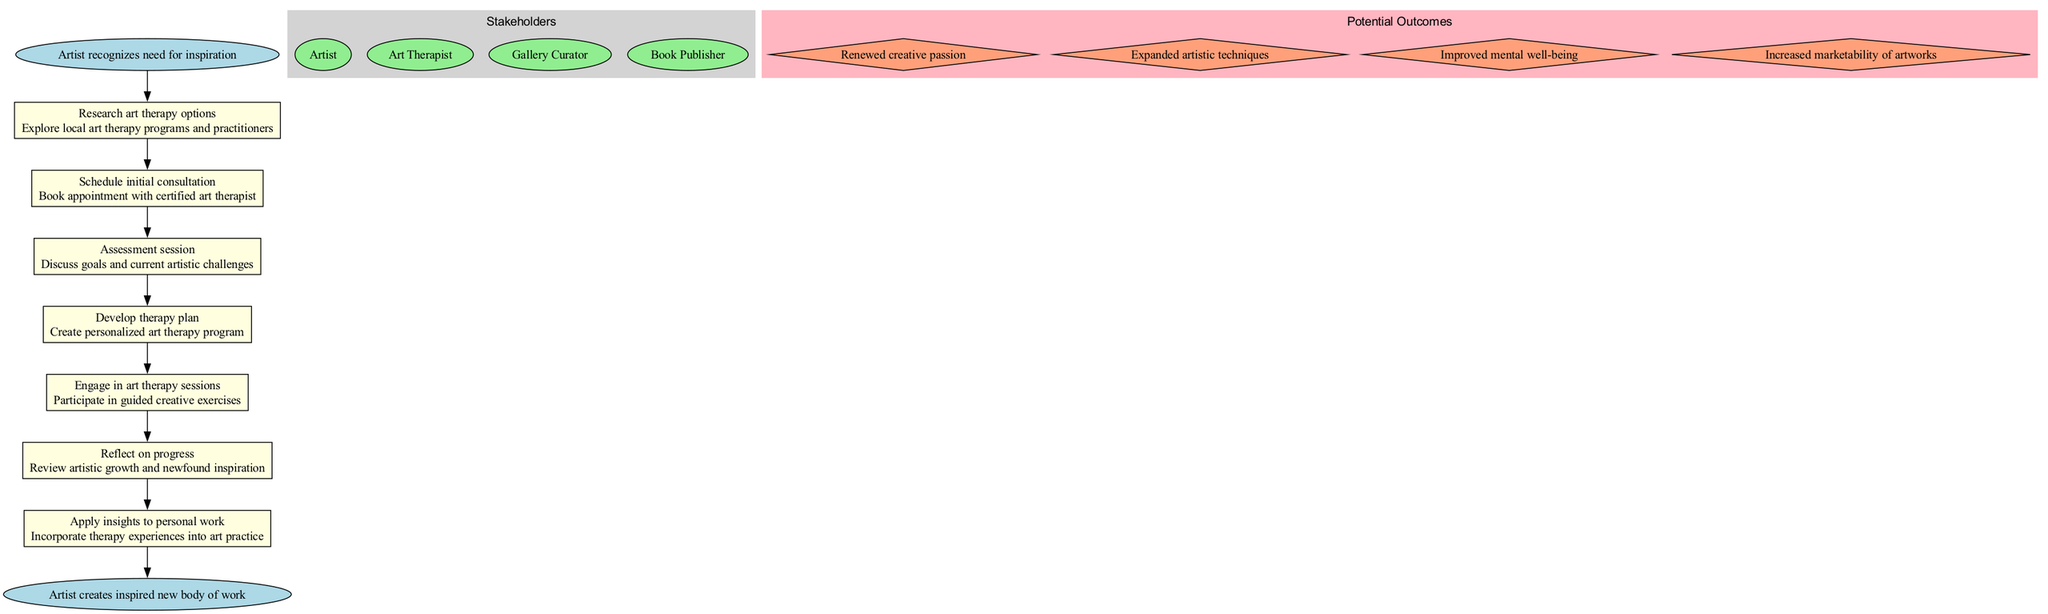What is the starting point of the artist's journey? The starting point listed in the diagram is “Artist recognizes need for inspiration.” This node clearly indicates the first step in the pathway.
Answer: Artist recognizes need for inspiration How many steps are there in the pathway? By counting the individual steps in the diagram, there are a total of seven defined steps from the beginning to the end point.
Answer: 7 What is the last step before the artist creates a new body of work? The last step before reaching the endpoint is “Apply insights to personal work.” This node connects the therapy experiences back to the artist's work.
Answer: Apply insights to personal work Which stakeholder is responsible for developing the therapy plan? The art therapist is responsible for developing the therapy plan according to the steps outlined in the pathway, specifically after the assessment session.
Answer: Art Therapist What potential outcome is centered around mental health? Among the listed potential outcomes, the one that pertains specifically to mental health is “Improved mental well-being.” This indicates a focus on the psychological benefits from the therapy.
Answer: Improved mental well-being What connects each step in the pathway? Each step in the pathway is connected by directed edges, which indicate the progression from one step to the next seamlessly.
Answer: Directed edges How does the artist reflect on their journey? The artist reflects on their journey in the step titled “Reflect on progress,” where they review their artistic growth and newfound inspiration.
Answer: Reflect on progress What is the endpoint of the artist's journey? The endpoint of the journey is stated as “Artist creates inspired new body of work,” marking the culmination of the therapy process.
Answer: Artist creates inspired new body of work What step involves engaging in guided creative exercises? The step that involves engaging in guided creative exercises is labeled “Engage in art therapy sessions,” where the artist participates actively in the therapy process.
Answer: Engage in art therapy sessions 